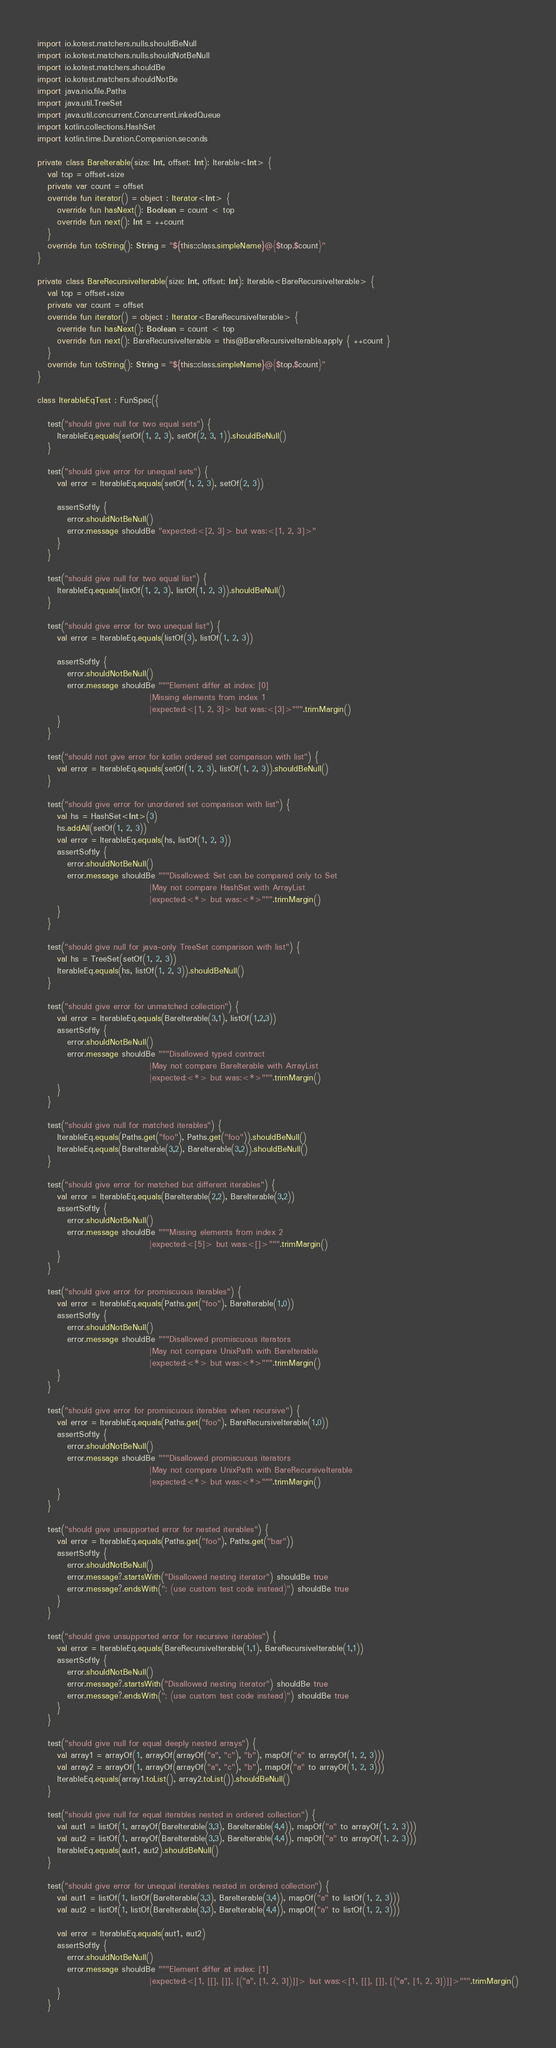<code> <loc_0><loc_0><loc_500><loc_500><_Kotlin_>import io.kotest.matchers.nulls.shouldBeNull
import io.kotest.matchers.nulls.shouldNotBeNull
import io.kotest.matchers.shouldBe
import io.kotest.matchers.shouldNotBe
import java.nio.file.Paths
import java.util.TreeSet
import java.util.concurrent.ConcurrentLinkedQueue
import kotlin.collections.HashSet
import kotlin.time.Duration.Companion.seconds

private class BareIterable(size: Int, offset: Int): Iterable<Int> {
   val top = offset+size
   private var count = offset
   override fun iterator() = object : Iterator<Int> {
      override fun hasNext(): Boolean = count < top
      override fun next(): Int = ++count
   }
   override fun toString(): String = "${this::class.simpleName}@{$top,$count}"
}

private class BareRecursiveIterable(size: Int, offset: Int): Iterable<BareRecursiveIterable> {
   val top = offset+size
   private var count = offset
   override fun iterator() = object : Iterator<BareRecursiveIterable> {
      override fun hasNext(): Boolean = count < top
      override fun next(): BareRecursiveIterable = this@BareRecursiveIterable.apply { ++count }
   }
   override fun toString(): String = "${this::class.simpleName}@{$top,$count}"
}

class IterableEqTest : FunSpec({

   test("should give null for two equal sets") {
      IterableEq.equals(setOf(1, 2, 3), setOf(2, 3, 1)).shouldBeNull()
   }

   test("should give error for unequal sets") {
      val error = IterableEq.equals(setOf(1, 2, 3), setOf(2, 3))

      assertSoftly {
         error.shouldNotBeNull()
         error.message shouldBe "expected:<[2, 3]> but was:<[1, 2, 3]>"
      }
   }

   test("should give null for two equal list") {
      IterableEq.equals(listOf(1, 2, 3), listOf(1, 2, 3)).shouldBeNull()
   }

   test("should give error for two unequal list") {
      val error = IterableEq.equals(listOf(3), listOf(1, 2, 3))

      assertSoftly {
         error.shouldNotBeNull()
         error.message shouldBe """Element differ at index: [0]
                                  |Missing elements from index 1
                                  |expected:<[1, 2, 3]> but was:<[3]>""".trimMargin()
      }
   }

   test("should not give error for kotlin ordered set comparison with list") {
      val error = IterableEq.equals(setOf(1, 2, 3), listOf(1, 2, 3)).shouldBeNull()
   }

   test("should give error for unordered set comparison with list") {
      val hs = HashSet<Int>(3)
      hs.addAll(setOf(1, 2, 3))
      val error = IterableEq.equals(hs, listOf(1, 2, 3))
      assertSoftly {
         error.shouldNotBeNull()
         error.message shouldBe """Disallowed: Set can be compared only to Set
                                  |May not compare HashSet with ArrayList
                                  |expected:<*> but was:<*>""".trimMargin()
      }
   }

   test("should give null for java-only TreeSet comparison with list") {
      val hs = TreeSet(setOf(1, 2, 3))
      IterableEq.equals(hs, listOf(1, 2, 3)).shouldBeNull()
   }

   test("should give error for unmatched collection") {
      val error = IterableEq.equals(BareIterable(3,1), listOf(1,2,3))
      assertSoftly {
         error.shouldNotBeNull()
         error.message shouldBe """Disallowed typed contract
                                  |May not compare BareIterable with ArrayList
                                  |expected:<*> but was:<*>""".trimMargin()
      }
   }

   test("should give null for matched iterables") {
      IterableEq.equals(Paths.get("foo"), Paths.get("foo")).shouldBeNull()
      IterableEq.equals(BareIterable(3,2), BareIterable(3,2)).shouldBeNull()
   }

   test("should give error for matched but different iterables") {
      val error = IterableEq.equals(BareIterable(2,2), BareIterable(3,2))
      assertSoftly {
         error.shouldNotBeNull()
         error.message shouldBe """Missing elements from index 2
                                  |expected:<[5]> but was:<[]>""".trimMargin()
      }
   }

   test("should give error for promiscuous iterables") {
      val error = IterableEq.equals(Paths.get("foo"), BareIterable(1,0))
      assertSoftly {
         error.shouldNotBeNull()
         error.message shouldBe """Disallowed promiscuous iterators
                                  |May not compare UnixPath with BareIterable
                                  |expected:<*> but was:<*>""".trimMargin()
      }
   }

   test("should give error for promiscuous iterables when recursive") {
      val error = IterableEq.equals(Paths.get("foo"), BareRecursiveIterable(1,0))
      assertSoftly {
         error.shouldNotBeNull()
         error.message shouldBe """Disallowed promiscuous iterators
                                  |May not compare UnixPath with BareRecursiveIterable
                                  |expected:<*> but was:<*>""".trimMargin()
      }
   }

   test("should give unsupported error for nested iterables") {
      val error = IterableEq.equals(Paths.get("foo"), Paths.get("bar"))
      assertSoftly {
         error.shouldNotBeNull()
         error.message?.startsWith("Disallowed nesting iterator") shouldBe true
         error.message?.endsWith("; (use custom test code instead)") shouldBe true
      }
   }

   test("should give unsupported error for recursive iterables") {
      val error = IterableEq.equals(BareRecursiveIterable(1,1), BareRecursiveIterable(1,1))
      assertSoftly {
         error.shouldNotBeNull()
         error.message?.startsWith("Disallowed nesting iterator") shouldBe true
         error.message?.endsWith("; (use custom test code instead)") shouldBe true
      }
   }

   test("should give null for equal deeply nested arrays") {
      val array1 = arrayOf(1, arrayOf(arrayOf("a", "c"), "b"), mapOf("a" to arrayOf(1, 2, 3)))
      val array2 = arrayOf(1, arrayOf(arrayOf("a", "c"), "b"), mapOf("a" to arrayOf(1, 2, 3)))
      IterableEq.equals(array1.toList(), array2.toList()).shouldBeNull()
   }

   test("should give null for equal iterables nested in ordered collection") {
      val aut1 = listOf(1, arrayOf(BareIterable(3,3), BareIterable(4,4)), mapOf("a" to arrayOf(1, 2, 3)))
      val aut2 = listOf(1, arrayOf(BareIterable(3,3), BareIterable(4,4)), mapOf("a" to arrayOf(1, 2, 3)))
      IterableEq.equals(aut1, aut2).shouldBeNull()
   }

   test("should give error for unequal iterables nested in ordered collection") {
      val aut1 = listOf(1, listOf(BareIterable(3,3), BareIterable(3,4)), mapOf("a" to listOf(1, 2, 3)))
      val aut2 = listOf(1, listOf(BareIterable(3,3), BareIterable(4,4)), mapOf("a" to listOf(1, 2, 3)))

      val error = IterableEq.equals(aut1, aut2)
      assertSoftly {
         error.shouldNotBeNull()
         error.message shouldBe """Element differ at index: [1]
                                  |expected:<[1, [[], []], [("a", [1, 2, 3])]]> but was:<[1, [[], []], [("a", [1, 2, 3])]]>""".trimMargin()
      }
   }
</code> 